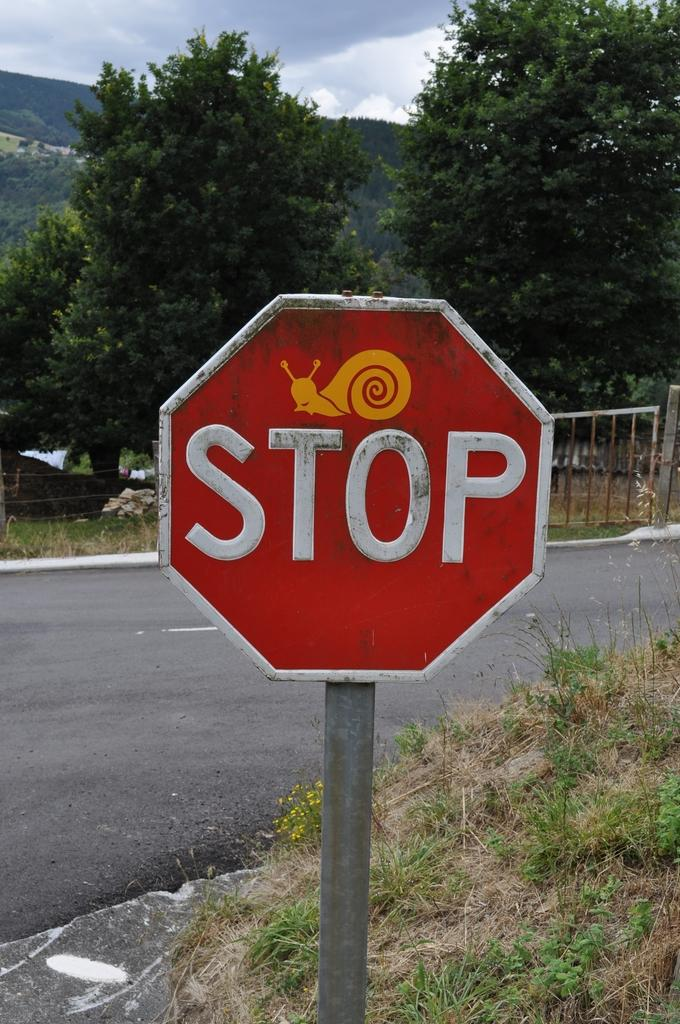<image>
Create a compact narrative representing the image presented. A red and white stop sign that has an image of a snail over the top of it. 